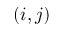Convert formula to latex. <formula><loc_0><loc_0><loc_500><loc_500>( i , j )</formula> 